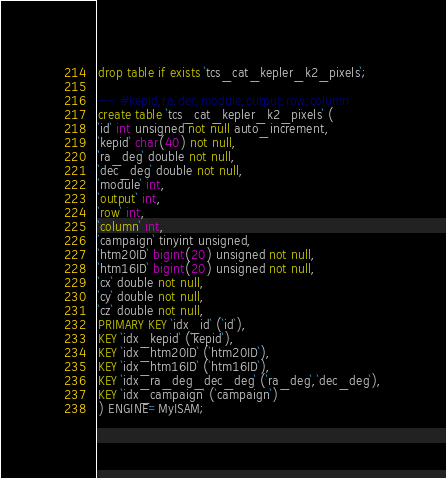<code> <loc_0><loc_0><loc_500><loc_500><_SQL_>drop table if exists `tcs_cat_kepler_k2_pixels`;

-- #kepid,ra,dec,module,output,row,column
create table `tcs_cat_kepler_k2_pixels` (
`id` int unsigned not null auto_increment,
`kepid` char(40) not null,
`ra_deg` double not null,
`dec_deg` double not null,
`module` int,
`output` int,
`row` int,
`column` int,
`campaign` tinyint unsigned,
`htm20ID` bigint(20) unsigned not null,
`htm16ID` bigint(20) unsigned not null,
`cx` double not null,
`cy` double not null,
`cz` double not null,
PRIMARY KEY `idx_id` (`id`),
KEY `idx_kepid` (`kepid`),
KEY `idx_htm20ID` (`htm20ID`),
KEY `idx_htm16ID` (`htm16ID`),
KEY `idx_ra_deg_dec_deg` (`ra_deg`,`dec_deg`),
KEY `idx_campaign` (`campaign`)
) ENGINE=MyISAM;
</code> 